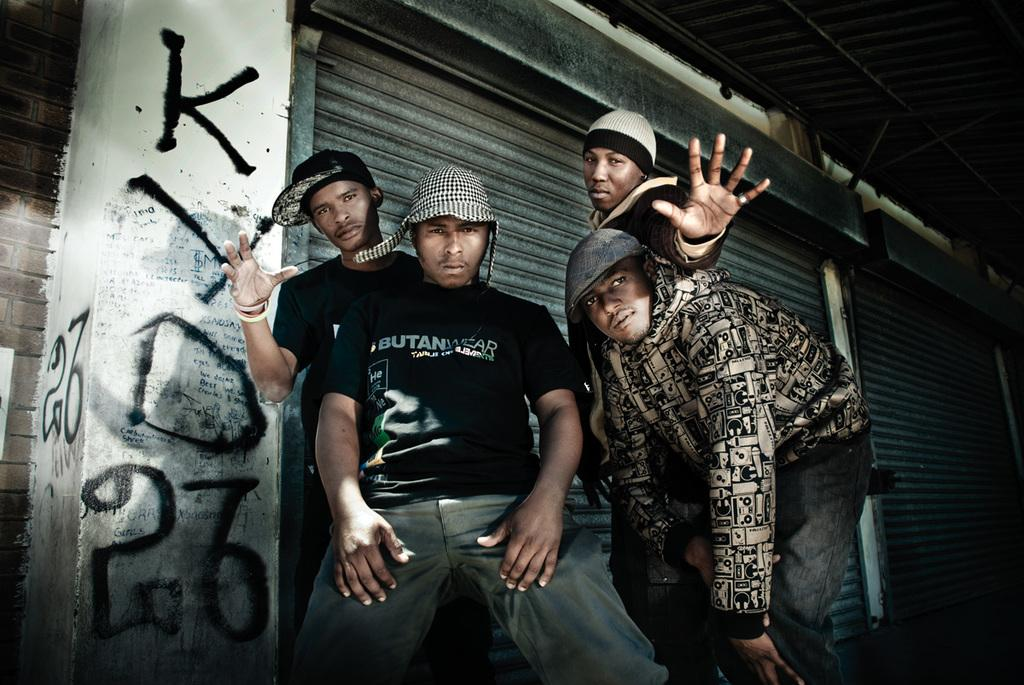How many people are in the image? There are four men in the image. What objects can be seen in the image besides the men? Metal rods and rolling shutters are visible in the image. What type of brush is being used by one of the men in the image? There is no brush present in the image; the men are not using any tools or objects besides the metal rods and rolling shutters. 